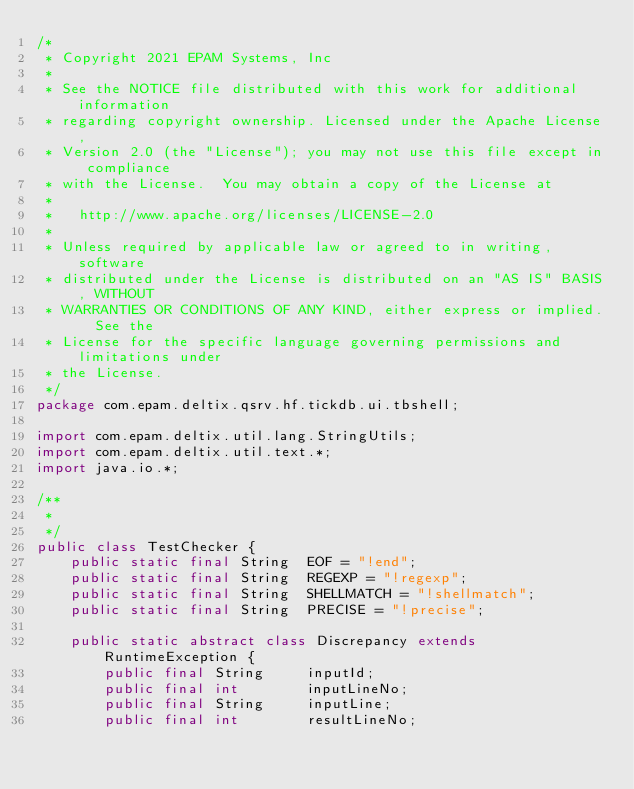<code> <loc_0><loc_0><loc_500><loc_500><_Java_>/*
 * Copyright 2021 EPAM Systems, Inc
 *
 * See the NOTICE file distributed with this work for additional information
 * regarding copyright ownership. Licensed under the Apache License,
 * Version 2.0 (the "License"); you may not use this file except in compliance
 * with the License.  You may obtain a copy of the License at
 *
 *   http://www.apache.org/licenses/LICENSE-2.0
 *
 * Unless required by applicable law or agreed to in writing, software
 * distributed under the License is distributed on an "AS IS" BASIS, WITHOUT
 * WARRANTIES OR CONDITIONS OF ANY KIND, either express or implied.  See the
 * License for the specific language governing permissions and limitations under
 * the License.
 */
package com.epam.deltix.qsrv.hf.tickdb.ui.tbshell;

import com.epam.deltix.util.lang.StringUtils;
import com.epam.deltix.util.text.*;
import java.io.*;

/**
 *
 */
public class TestChecker {
    public static final String  EOF = "!end";
    public static final String  REGEXP = "!regexp";
    public static final String  SHELLMATCH = "!shellmatch";
    public static final String  PRECISE = "!precise";
    
    public static abstract class Discrepancy extends RuntimeException {
        public final String     inputId;
        public final int        inputLineNo;
        public final String     inputLine;
        public final int        resultLineNo;</code> 